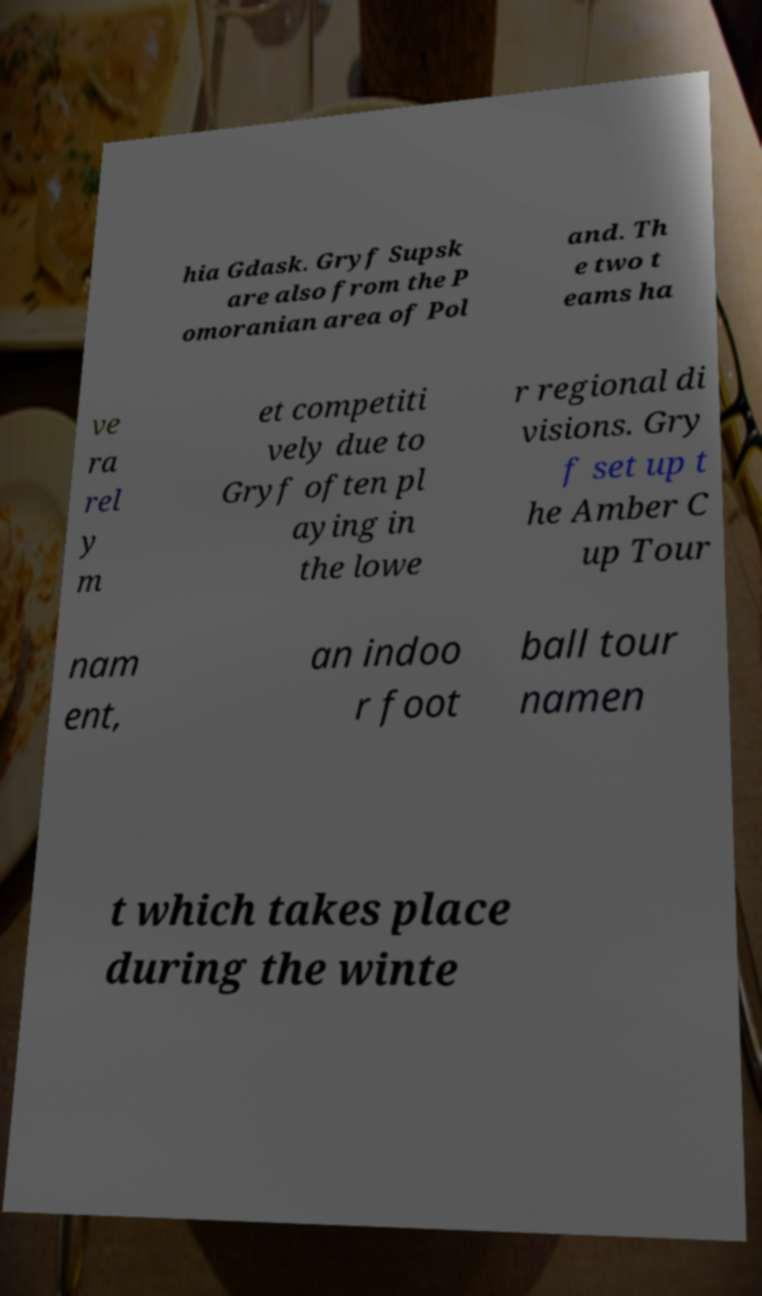Can you read and provide the text displayed in the image?This photo seems to have some interesting text. Can you extract and type it out for me? hia Gdask. Gryf Supsk are also from the P omoranian area of Pol and. Th e two t eams ha ve ra rel y m et competiti vely due to Gryf often pl aying in the lowe r regional di visions. Gry f set up t he Amber C up Tour nam ent, an indoo r foot ball tour namen t which takes place during the winte 